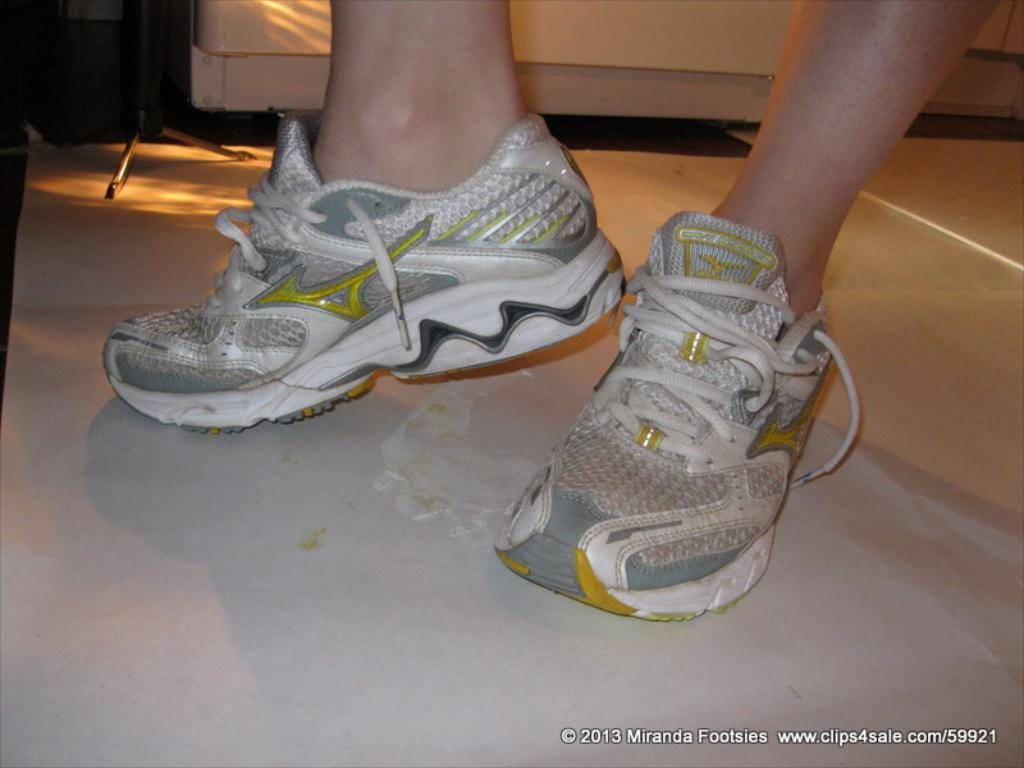What type of shoe can be seen in the image? There is a white color shoe in the image. What object is visible in the background of the image? There is a tripod stand in the background of the image. What else can be seen in the background of the image? Furniture is present in the background of the image. What type of paste is being used to stick the shoe to the tripod stand in the image? There is no paste or any indication of the shoe being stuck to the tripod stand in the image. 